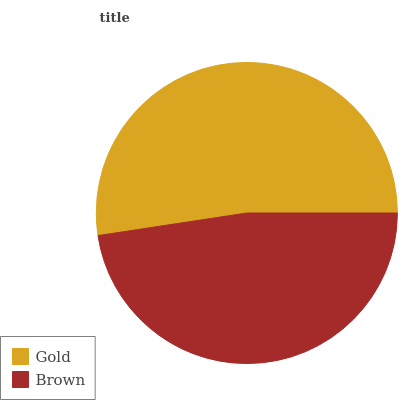Is Brown the minimum?
Answer yes or no. Yes. Is Gold the maximum?
Answer yes or no. Yes. Is Brown the maximum?
Answer yes or no. No. Is Gold greater than Brown?
Answer yes or no. Yes. Is Brown less than Gold?
Answer yes or no. Yes. Is Brown greater than Gold?
Answer yes or no. No. Is Gold less than Brown?
Answer yes or no. No. Is Gold the high median?
Answer yes or no. Yes. Is Brown the low median?
Answer yes or no. Yes. Is Brown the high median?
Answer yes or no. No. Is Gold the low median?
Answer yes or no. No. 